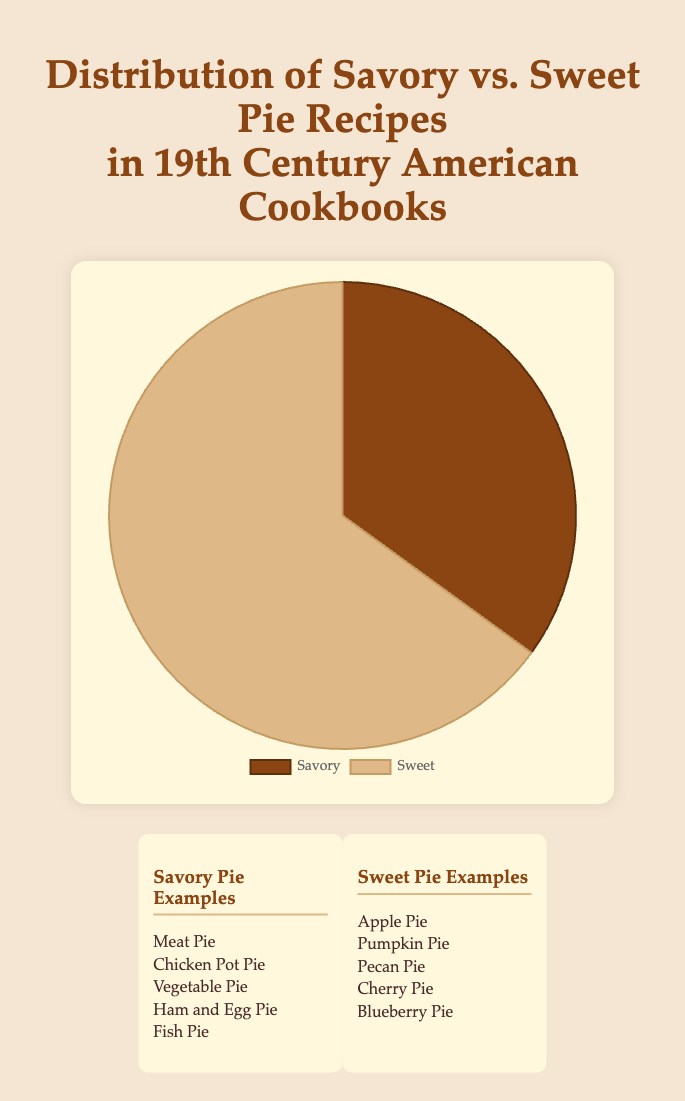What percentage of the pie recipes in 19th-century American cookbooks are savory? To find the percentage, divide the number of savory pie recipes by the total number of pie recipes and multiply by 100. The total number of pie recipes is 100 (35 savory + 65 sweet). So, (35/100) * 100 = 35%
Answer: 35% How many more sweet pie recipes are there compared to savory pie recipes in 19th-century American cookbooks? Subtract the number of savory pie recipes from the number of sweet pie recipes. So, 65 (sweet) - 35 (savory) = 30
Answer: 30 If each savory pie recipe was represented by a 10-degree segment in the pie chart, what would be the total degrees for sweet pie recipes? Each savory recipe represents 10 degrees. For 35 savory recipes, that's 35 * 10 = 350 degrees. Since a full pie chart is 360 degrees, the sweet recipes would then take up 360 - 350 = 10 degrees. However, this is incorrect as visually the representation should sum to the full 360 degrees with the correct portioning. Alternatively, correct this logically. Since there are 100 recipes, and only 65 percent for sweet, this should be 65 percent of a circle of 360 degrees, 0.65 * 360 = 234 degrees
Answer: 234 degrees How can you describe the color used to represent sweet pie recipes in the pie chart? The sweet pie recipes are represented by a light brown color in the pie chart, visually appearing similar to the tone of 'burlywood'.
Answer: Light brown (burlywood) What is the ratio of sweet to savory pie recipes in the chart? The count of sweet pie recipes is 65, and the count of savory pie recipes is 35. Thus, the ratio of sweet to savory is 65:35, which can be simplified by dividing both numbers by 5. So, 65/5 : 35/5 = 13:7
Answer: 13:7 If you were to combine both types of pie recipes into a single category, what would be the new total count? Add the number of savory pie recipes to the number of sweet pie recipes: 35 (savory) + 65 (sweet) = 100
Answer: 100 What visual difference on the pie chart indicates the prominence of sweet pies over savory pies? In the pie chart, the segment representing sweet pie recipes is significantly larger than the segment representing savory pie recipes, visually showing that sweet pies dominate.
Answer: Larger segment If we were to add another 15 savory pie recipes to the dataset, what would be the new percentage of savory pie recipes? Adding 15 savory pie recipes would increase the count to 35 + 15 = 50 savory pie recipes. The new total count of pie recipes would be 50 (savory) + 65 (sweet) = 115. The percentage of savory pies would then be (50/115) * 100 = approximately 43.48%.
Answer: Approximately 43.48% 